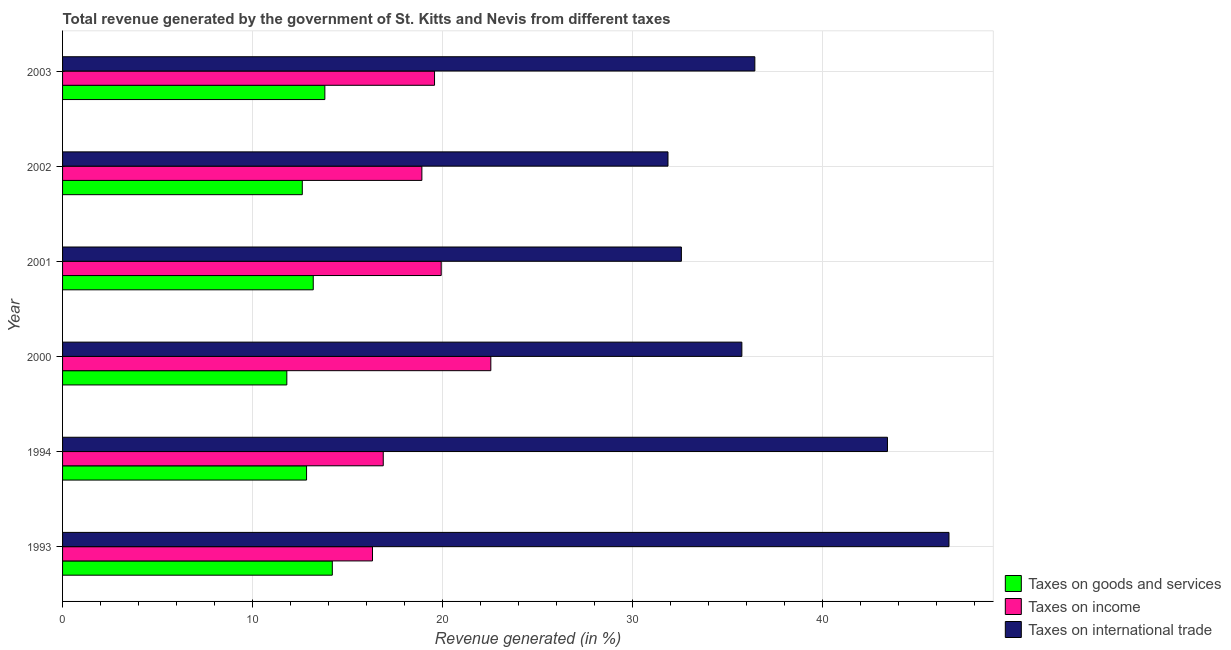How many different coloured bars are there?
Keep it short and to the point. 3. How many groups of bars are there?
Give a very brief answer. 6. Are the number of bars on each tick of the Y-axis equal?
Give a very brief answer. Yes. How many bars are there on the 5th tick from the top?
Give a very brief answer. 3. In how many cases, is the number of bars for a given year not equal to the number of legend labels?
Your response must be concise. 0. What is the percentage of revenue generated by taxes on goods and services in 1994?
Ensure brevity in your answer.  12.84. Across all years, what is the maximum percentage of revenue generated by tax on international trade?
Your response must be concise. 46.64. Across all years, what is the minimum percentage of revenue generated by tax on international trade?
Provide a succinct answer. 31.86. In which year was the percentage of revenue generated by taxes on goods and services maximum?
Make the answer very short. 1993. In which year was the percentage of revenue generated by tax on international trade minimum?
Provide a short and direct response. 2002. What is the total percentage of revenue generated by taxes on income in the graph?
Offer a terse response. 114.12. What is the difference between the percentage of revenue generated by tax on international trade in 1994 and that in 2001?
Provide a short and direct response. 10.84. What is the difference between the percentage of revenue generated by tax on international trade in 2000 and the percentage of revenue generated by taxes on income in 2003?
Give a very brief answer. 16.17. What is the average percentage of revenue generated by taxes on goods and services per year?
Ensure brevity in your answer.  13.07. In the year 1994, what is the difference between the percentage of revenue generated by taxes on goods and services and percentage of revenue generated by taxes on income?
Ensure brevity in your answer.  -4.04. What is the ratio of the percentage of revenue generated by taxes on income in 1994 to that in 2000?
Make the answer very short. 0.75. Is the percentage of revenue generated by tax on international trade in 1994 less than that in 2000?
Provide a short and direct response. No. Is the difference between the percentage of revenue generated by taxes on income in 2001 and 2003 greater than the difference between the percentage of revenue generated by taxes on goods and services in 2001 and 2003?
Provide a succinct answer. Yes. What is the difference between the highest and the second highest percentage of revenue generated by taxes on goods and services?
Make the answer very short. 0.39. What is the difference between the highest and the lowest percentage of revenue generated by taxes on goods and services?
Your answer should be very brief. 2.39. In how many years, is the percentage of revenue generated by taxes on income greater than the average percentage of revenue generated by taxes on income taken over all years?
Your answer should be very brief. 3. What does the 1st bar from the top in 1994 represents?
Provide a short and direct response. Taxes on international trade. What does the 3rd bar from the bottom in 2001 represents?
Provide a succinct answer. Taxes on international trade. How many bars are there?
Offer a terse response. 18. Does the graph contain grids?
Make the answer very short. Yes. Where does the legend appear in the graph?
Offer a very short reply. Bottom right. How many legend labels are there?
Your answer should be compact. 3. How are the legend labels stacked?
Your answer should be compact. Vertical. What is the title of the graph?
Offer a very short reply. Total revenue generated by the government of St. Kitts and Nevis from different taxes. What is the label or title of the X-axis?
Your answer should be very brief. Revenue generated (in %). What is the label or title of the Y-axis?
Your answer should be very brief. Year. What is the Revenue generated (in %) in Taxes on goods and services in 1993?
Keep it short and to the point. 14.19. What is the Revenue generated (in %) of Taxes on income in 1993?
Your answer should be very brief. 16.31. What is the Revenue generated (in %) in Taxes on international trade in 1993?
Your answer should be compact. 46.64. What is the Revenue generated (in %) of Taxes on goods and services in 1994?
Offer a terse response. 12.84. What is the Revenue generated (in %) of Taxes on income in 1994?
Give a very brief answer. 16.87. What is the Revenue generated (in %) in Taxes on international trade in 1994?
Ensure brevity in your answer.  43.41. What is the Revenue generated (in %) of Taxes on goods and services in 2000?
Your response must be concise. 11.8. What is the Revenue generated (in %) of Taxes on income in 2000?
Your answer should be very brief. 22.54. What is the Revenue generated (in %) in Taxes on international trade in 2000?
Make the answer very short. 35.74. What is the Revenue generated (in %) in Taxes on goods and services in 2001?
Offer a very short reply. 13.19. What is the Revenue generated (in %) in Taxes on income in 2001?
Your answer should be very brief. 19.92. What is the Revenue generated (in %) of Taxes on international trade in 2001?
Ensure brevity in your answer.  32.56. What is the Revenue generated (in %) of Taxes on goods and services in 2002?
Your answer should be very brief. 12.61. What is the Revenue generated (in %) of Taxes on income in 2002?
Give a very brief answer. 18.91. What is the Revenue generated (in %) of Taxes on international trade in 2002?
Provide a succinct answer. 31.86. What is the Revenue generated (in %) of Taxes on goods and services in 2003?
Give a very brief answer. 13.8. What is the Revenue generated (in %) of Taxes on income in 2003?
Provide a succinct answer. 19.57. What is the Revenue generated (in %) of Taxes on international trade in 2003?
Your answer should be compact. 36.43. Across all years, what is the maximum Revenue generated (in %) in Taxes on goods and services?
Provide a succinct answer. 14.19. Across all years, what is the maximum Revenue generated (in %) in Taxes on income?
Provide a succinct answer. 22.54. Across all years, what is the maximum Revenue generated (in %) in Taxes on international trade?
Provide a succinct answer. 46.64. Across all years, what is the minimum Revenue generated (in %) of Taxes on goods and services?
Provide a short and direct response. 11.8. Across all years, what is the minimum Revenue generated (in %) of Taxes on income?
Provide a short and direct response. 16.31. Across all years, what is the minimum Revenue generated (in %) of Taxes on international trade?
Give a very brief answer. 31.86. What is the total Revenue generated (in %) of Taxes on goods and services in the graph?
Your answer should be compact. 78.44. What is the total Revenue generated (in %) in Taxes on income in the graph?
Ensure brevity in your answer.  114.12. What is the total Revenue generated (in %) of Taxes on international trade in the graph?
Make the answer very short. 226.64. What is the difference between the Revenue generated (in %) in Taxes on goods and services in 1993 and that in 1994?
Provide a succinct answer. 1.35. What is the difference between the Revenue generated (in %) of Taxes on income in 1993 and that in 1994?
Offer a terse response. -0.57. What is the difference between the Revenue generated (in %) of Taxes on international trade in 1993 and that in 1994?
Give a very brief answer. 3.24. What is the difference between the Revenue generated (in %) in Taxes on goods and services in 1993 and that in 2000?
Give a very brief answer. 2.39. What is the difference between the Revenue generated (in %) in Taxes on income in 1993 and that in 2000?
Make the answer very short. -6.23. What is the difference between the Revenue generated (in %) of Taxes on international trade in 1993 and that in 2000?
Your answer should be compact. 10.9. What is the difference between the Revenue generated (in %) in Taxes on income in 1993 and that in 2001?
Offer a very short reply. -3.62. What is the difference between the Revenue generated (in %) in Taxes on international trade in 1993 and that in 2001?
Your answer should be compact. 14.08. What is the difference between the Revenue generated (in %) in Taxes on goods and services in 1993 and that in 2002?
Keep it short and to the point. 1.58. What is the difference between the Revenue generated (in %) in Taxes on income in 1993 and that in 2002?
Keep it short and to the point. -2.6. What is the difference between the Revenue generated (in %) in Taxes on international trade in 1993 and that in 2002?
Provide a short and direct response. 14.79. What is the difference between the Revenue generated (in %) in Taxes on goods and services in 1993 and that in 2003?
Give a very brief answer. 0.39. What is the difference between the Revenue generated (in %) of Taxes on income in 1993 and that in 2003?
Offer a terse response. -3.26. What is the difference between the Revenue generated (in %) in Taxes on international trade in 1993 and that in 2003?
Your answer should be compact. 10.22. What is the difference between the Revenue generated (in %) of Taxes on goods and services in 1994 and that in 2000?
Make the answer very short. 1.04. What is the difference between the Revenue generated (in %) of Taxes on income in 1994 and that in 2000?
Make the answer very short. -5.66. What is the difference between the Revenue generated (in %) of Taxes on international trade in 1994 and that in 2000?
Keep it short and to the point. 7.66. What is the difference between the Revenue generated (in %) in Taxes on goods and services in 1994 and that in 2001?
Your answer should be compact. -0.35. What is the difference between the Revenue generated (in %) in Taxes on income in 1994 and that in 2001?
Offer a terse response. -3.05. What is the difference between the Revenue generated (in %) in Taxes on international trade in 1994 and that in 2001?
Ensure brevity in your answer.  10.84. What is the difference between the Revenue generated (in %) in Taxes on goods and services in 1994 and that in 2002?
Your response must be concise. 0.22. What is the difference between the Revenue generated (in %) of Taxes on income in 1994 and that in 2002?
Provide a short and direct response. -2.03. What is the difference between the Revenue generated (in %) in Taxes on international trade in 1994 and that in 2002?
Give a very brief answer. 11.55. What is the difference between the Revenue generated (in %) of Taxes on goods and services in 1994 and that in 2003?
Keep it short and to the point. -0.96. What is the difference between the Revenue generated (in %) in Taxes on income in 1994 and that in 2003?
Ensure brevity in your answer.  -2.7. What is the difference between the Revenue generated (in %) in Taxes on international trade in 1994 and that in 2003?
Ensure brevity in your answer.  6.98. What is the difference between the Revenue generated (in %) in Taxes on goods and services in 2000 and that in 2001?
Provide a short and direct response. -1.39. What is the difference between the Revenue generated (in %) of Taxes on income in 2000 and that in 2001?
Provide a succinct answer. 2.61. What is the difference between the Revenue generated (in %) in Taxes on international trade in 2000 and that in 2001?
Offer a terse response. 3.18. What is the difference between the Revenue generated (in %) in Taxes on goods and services in 2000 and that in 2002?
Your answer should be compact. -0.81. What is the difference between the Revenue generated (in %) of Taxes on income in 2000 and that in 2002?
Offer a terse response. 3.63. What is the difference between the Revenue generated (in %) of Taxes on international trade in 2000 and that in 2002?
Provide a short and direct response. 3.89. What is the difference between the Revenue generated (in %) in Taxes on goods and services in 2000 and that in 2003?
Ensure brevity in your answer.  -2. What is the difference between the Revenue generated (in %) in Taxes on income in 2000 and that in 2003?
Ensure brevity in your answer.  2.96. What is the difference between the Revenue generated (in %) in Taxes on international trade in 2000 and that in 2003?
Your answer should be compact. -0.68. What is the difference between the Revenue generated (in %) of Taxes on goods and services in 2001 and that in 2002?
Provide a succinct answer. 0.58. What is the difference between the Revenue generated (in %) of Taxes on income in 2001 and that in 2002?
Give a very brief answer. 1.02. What is the difference between the Revenue generated (in %) in Taxes on international trade in 2001 and that in 2002?
Provide a short and direct response. 0.71. What is the difference between the Revenue generated (in %) in Taxes on goods and services in 2001 and that in 2003?
Your response must be concise. -0.61. What is the difference between the Revenue generated (in %) of Taxes on income in 2001 and that in 2003?
Your answer should be very brief. 0.35. What is the difference between the Revenue generated (in %) in Taxes on international trade in 2001 and that in 2003?
Provide a succinct answer. -3.87. What is the difference between the Revenue generated (in %) in Taxes on goods and services in 2002 and that in 2003?
Ensure brevity in your answer.  -1.19. What is the difference between the Revenue generated (in %) of Taxes on income in 2002 and that in 2003?
Your answer should be very brief. -0.67. What is the difference between the Revenue generated (in %) in Taxes on international trade in 2002 and that in 2003?
Provide a short and direct response. -4.57. What is the difference between the Revenue generated (in %) in Taxes on goods and services in 1993 and the Revenue generated (in %) in Taxes on income in 1994?
Your response must be concise. -2.68. What is the difference between the Revenue generated (in %) in Taxes on goods and services in 1993 and the Revenue generated (in %) in Taxes on international trade in 1994?
Make the answer very short. -29.21. What is the difference between the Revenue generated (in %) of Taxes on income in 1993 and the Revenue generated (in %) of Taxes on international trade in 1994?
Make the answer very short. -27.1. What is the difference between the Revenue generated (in %) in Taxes on goods and services in 1993 and the Revenue generated (in %) in Taxes on income in 2000?
Your response must be concise. -8.34. What is the difference between the Revenue generated (in %) in Taxes on goods and services in 1993 and the Revenue generated (in %) in Taxes on international trade in 2000?
Give a very brief answer. -21.55. What is the difference between the Revenue generated (in %) in Taxes on income in 1993 and the Revenue generated (in %) in Taxes on international trade in 2000?
Your answer should be compact. -19.44. What is the difference between the Revenue generated (in %) in Taxes on goods and services in 1993 and the Revenue generated (in %) in Taxes on income in 2001?
Your answer should be compact. -5.73. What is the difference between the Revenue generated (in %) in Taxes on goods and services in 1993 and the Revenue generated (in %) in Taxes on international trade in 2001?
Make the answer very short. -18.37. What is the difference between the Revenue generated (in %) in Taxes on income in 1993 and the Revenue generated (in %) in Taxes on international trade in 2001?
Give a very brief answer. -16.25. What is the difference between the Revenue generated (in %) of Taxes on goods and services in 1993 and the Revenue generated (in %) of Taxes on income in 2002?
Provide a succinct answer. -4.71. What is the difference between the Revenue generated (in %) in Taxes on goods and services in 1993 and the Revenue generated (in %) in Taxes on international trade in 2002?
Make the answer very short. -17.66. What is the difference between the Revenue generated (in %) of Taxes on income in 1993 and the Revenue generated (in %) of Taxes on international trade in 2002?
Your answer should be very brief. -15.55. What is the difference between the Revenue generated (in %) of Taxes on goods and services in 1993 and the Revenue generated (in %) of Taxes on income in 2003?
Make the answer very short. -5.38. What is the difference between the Revenue generated (in %) in Taxes on goods and services in 1993 and the Revenue generated (in %) in Taxes on international trade in 2003?
Offer a very short reply. -22.23. What is the difference between the Revenue generated (in %) in Taxes on income in 1993 and the Revenue generated (in %) in Taxes on international trade in 2003?
Your answer should be very brief. -20.12. What is the difference between the Revenue generated (in %) in Taxes on goods and services in 1994 and the Revenue generated (in %) in Taxes on income in 2000?
Offer a terse response. -9.7. What is the difference between the Revenue generated (in %) of Taxes on goods and services in 1994 and the Revenue generated (in %) of Taxes on international trade in 2000?
Ensure brevity in your answer.  -22.91. What is the difference between the Revenue generated (in %) of Taxes on income in 1994 and the Revenue generated (in %) of Taxes on international trade in 2000?
Make the answer very short. -18.87. What is the difference between the Revenue generated (in %) of Taxes on goods and services in 1994 and the Revenue generated (in %) of Taxes on income in 2001?
Make the answer very short. -7.09. What is the difference between the Revenue generated (in %) in Taxes on goods and services in 1994 and the Revenue generated (in %) in Taxes on international trade in 2001?
Keep it short and to the point. -19.72. What is the difference between the Revenue generated (in %) in Taxes on income in 1994 and the Revenue generated (in %) in Taxes on international trade in 2001?
Give a very brief answer. -15.69. What is the difference between the Revenue generated (in %) of Taxes on goods and services in 1994 and the Revenue generated (in %) of Taxes on income in 2002?
Your response must be concise. -6.07. What is the difference between the Revenue generated (in %) in Taxes on goods and services in 1994 and the Revenue generated (in %) in Taxes on international trade in 2002?
Ensure brevity in your answer.  -19.02. What is the difference between the Revenue generated (in %) of Taxes on income in 1994 and the Revenue generated (in %) of Taxes on international trade in 2002?
Your response must be concise. -14.98. What is the difference between the Revenue generated (in %) in Taxes on goods and services in 1994 and the Revenue generated (in %) in Taxes on income in 2003?
Ensure brevity in your answer.  -6.73. What is the difference between the Revenue generated (in %) of Taxes on goods and services in 1994 and the Revenue generated (in %) of Taxes on international trade in 2003?
Ensure brevity in your answer.  -23.59. What is the difference between the Revenue generated (in %) in Taxes on income in 1994 and the Revenue generated (in %) in Taxes on international trade in 2003?
Offer a very short reply. -19.55. What is the difference between the Revenue generated (in %) in Taxes on goods and services in 2000 and the Revenue generated (in %) in Taxes on income in 2001?
Offer a very short reply. -8.12. What is the difference between the Revenue generated (in %) of Taxes on goods and services in 2000 and the Revenue generated (in %) of Taxes on international trade in 2001?
Your answer should be compact. -20.76. What is the difference between the Revenue generated (in %) in Taxes on income in 2000 and the Revenue generated (in %) in Taxes on international trade in 2001?
Your response must be concise. -10.03. What is the difference between the Revenue generated (in %) in Taxes on goods and services in 2000 and the Revenue generated (in %) in Taxes on income in 2002?
Make the answer very short. -7.11. What is the difference between the Revenue generated (in %) of Taxes on goods and services in 2000 and the Revenue generated (in %) of Taxes on international trade in 2002?
Make the answer very short. -20.06. What is the difference between the Revenue generated (in %) of Taxes on income in 2000 and the Revenue generated (in %) of Taxes on international trade in 2002?
Ensure brevity in your answer.  -9.32. What is the difference between the Revenue generated (in %) in Taxes on goods and services in 2000 and the Revenue generated (in %) in Taxes on income in 2003?
Ensure brevity in your answer.  -7.77. What is the difference between the Revenue generated (in %) of Taxes on goods and services in 2000 and the Revenue generated (in %) of Taxes on international trade in 2003?
Make the answer very short. -24.63. What is the difference between the Revenue generated (in %) in Taxes on income in 2000 and the Revenue generated (in %) in Taxes on international trade in 2003?
Make the answer very short. -13.89. What is the difference between the Revenue generated (in %) of Taxes on goods and services in 2001 and the Revenue generated (in %) of Taxes on income in 2002?
Provide a short and direct response. -5.72. What is the difference between the Revenue generated (in %) in Taxes on goods and services in 2001 and the Revenue generated (in %) in Taxes on international trade in 2002?
Your answer should be compact. -18.67. What is the difference between the Revenue generated (in %) in Taxes on income in 2001 and the Revenue generated (in %) in Taxes on international trade in 2002?
Offer a very short reply. -11.93. What is the difference between the Revenue generated (in %) of Taxes on goods and services in 2001 and the Revenue generated (in %) of Taxes on income in 2003?
Offer a terse response. -6.38. What is the difference between the Revenue generated (in %) of Taxes on goods and services in 2001 and the Revenue generated (in %) of Taxes on international trade in 2003?
Keep it short and to the point. -23.24. What is the difference between the Revenue generated (in %) in Taxes on income in 2001 and the Revenue generated (in %) in Taxes on international trade in 2003?
Provide a succinct answer. -16.5. What is the difference between the Revenue generated (in %) of Taxes on goods and services in 2002 and the Revenue generated (in %) of Taxes on income in 2003?
Keep it short and to the point. -6.96. What is the difference between the Revenue generated (in %) in Taxes on goods and services in 2002 and the Revenue generated (in %) in Taxes on international trade in 2003?
Your response must be concise. -23.81. What is the difference between the Revenue generated (in %) in Taxes on income in 2002 and the Revenue generated (in %) in Taxes on international trade in 2003?
Make the answer very short. -17.52. What is the average Revenue generated (in %) of Taxes on goods and services per year?
Offer a very short reply. 13.07. What is the average Revenue generated (in %) of Taxes on income per year?
Make the answer very short. 19.02. What is the average Revenue generated (in %) of Taxes on international trade per year?
Provide a short and direct response. 37.77. In the year 1993, what is the difference between the Revenue generated (in %) of Taxes on goods and services and Revenue generated (in %) of Taxes on income?
Ensure brevity in your answer.  -2.12. In the year 1993, what is the difference between the Revenue generated (in %) of Taxes on goods and services and Revenue generated (in %) of Taxes on international trade?
Provide a short and direct response. -32.45. In the year 1993, what is the difference between the Revenue generated (in %) in Taxes on income and Revenue generated (in %) in Taxes on international trade?
Give a very brief answer. -30.33. In the year 1994, what is the difference between the Revenue generated (in %) in Taxes on goods and services and Revenue generated (in %) in Taxes on income?
Offer a terse response. -4.04. In the year 1994, what is the difference between the Revenue generated (in %) in Taxes on goods and services and Revenue generated (in %) in Taxes on international trade?
Your response must be concise. -30.57. In the year 1994, what is the difference between the Revenue generated (in %) of Taxes on income and Revenue generated (in %) of Taxes on international trade?
Provide a succinct answer. -26.53. In the year 2000, what is the difference between the Revenue generated (in %) of Taxes on goods and services and Revenue generated (in %) of Taxes on income?
Provide a short and direct response. -10.73. In the year 2000, what is the difference between the Revenue generated (in %) in Taxes on goods and services and Revenue generated (in %) in Taxes on international trade?
Make the answer very short. -23.94. In the year 2000, what is the difference between the Revenue generated (in %) of Taxes on income and Revenue generated (in %) of Taxes on international trade?
Your answer should be compact. -13.21. In the year 2001, what is the difference between the Revenue generated (in %) in Taxes on goods and services and Revenue generated (in %) in Taxes on income?
Ensure brevity in your answer.  -6.73. In the year 2001, what is the difference between the Revenue generated (in %) of Taxes on goods and services and Revenue generated (in %) of Taxes on international trade?
Offer a terse response. -19.37. In the year 2001, what is the difference between the Revenue generated (in %) in Taxes on income and Revenue generated (in %) in Taxes on international trade?
Your answer should be very brief. -12.64. In the year 2002, what is the difference between the Revenue generated (in %) in Taxes on goods and services and Revenue generated (in %) in Taxes on income?
Your answer should be very brief. -6.29. In the year 2002, what is the difference between the Revenue generated (in %) of Taxes on goods and services and Revenue generated (in %) of Taxes on international trade?
Your response must be concise. -19.24. In the year 2002, what is the difference between the Revenue generated (in %) in Taxes on income and Revenue generated (in %) in Taxes on international trade?
Provide a succinct answer. -12.95. In the year 2003, what is the difference between the Revenue generated (in %) of Taxes on goods and services and Revenue generated (in %) of Taxes on income?
Make the answer very short. -5.77. In the year 2003, what is the difference between the Revenue generated (in %) of Taxes on goods and services and Revenue generated (in %) of Taxes on international trade?
Give a very brief answer. -22.63. In the year 2003, what is the difference between the Revenue generated (in %) in Taxes on income and Revenue generated (in %) in Taxes on international trade?
Provide a short and direct response. -16.86. What is the ratio of the Revenue generated (in %) of Taxes on goods and services in 1993 to that in 1994?
Your response must be concise. 1.11. What is the ratio of the Revenue generated (in %) of Taxes on income in 1993 to that in 1994?
Provide a succinct answer. 0.97. What is the ratio of the Revenue generated (in %) in Taxes on international trade in 1993 to that in 1994?
Offer a very short reply. 1.07. What is the ratio of the Revenue generated (in %) in Taxes on goods and services in 1993 to that in 2000?
Provide a succinct answer. 1.2. What is the ratio of the Revenue generated (in %) of Taxes on income in 1993 to that in 2000?
Ensure brevity in your answer.  0.72. What is the ratio of the Revenue generated (in %) of Taxes on international trade in 1993 to that in 2000?
Make the answer very short. 1.3. What is the ratio of the Revenue generated (in %) of Taxes on goods and services in 1993 to that in 2001?
Your response must be concise. 1.08. What is the ratio of the Revenue generated (in %) in Taxes on income in 1993 to that in 2001?
Keep it short and to the point. 0.82. What is the ratio of the Revenue generated (in %) in Taxes on international trade in 1993 to that in 2001?
Provide a short and direct response. 1.43. What is the ratio of the Revenue generated (in %) in Taxes on goods and services in 1993 to that in 2002?
Provide a short and direct response. 1.13. What is the ratio of the Revenue generated (in %) of Taxes on income in 1993 to that in 2002?
Keep it short and to the point. 0.86. What is the ratio of the Revenue generated (in %) of Taxes on international trade in 1993 to that in 2002?
Offer a very short reply. 1.46. What is the ratio of the Revenue generated (in %) in Taxes on goods and services in 1993 to that in 2003?
Give a very brief answer. 1.03. What is the ratio of the Revenue generated (in %) of Taxes on international trade in 1993 to that in 2003?
Give a very brief answer. 1.28. What is the ratio of the Revenue generated (in %) in Taxes on goods and services in 1994 to that in 2000?
Offer a very short reply. 1.09. What is the ratio of the Revenue generated (in %) in Taxes on income in 1994 to that in 2000?
Provide a succinct answer. 0.75. What is the ratio of the Revenue generated (in %) of Taxes on international trade in 1994 to that in 2000?
Keep it short and to the point. 1.21. What is the ratio of the Revenue generated (in %) in Taxes on goods and services in 1994 to that in 2001?
Your answer should be very brief. 0.97. What is the ratio of the Revenue generated (in %) in Taxes on income in 1994 to that in 2001?
Ensure brevity in your answer.  0.85. What is the ratio of the Revenue generated (in %) of Taxes on international trade in 1994 to that in 2001?
Provide a short and direct response. 1.33. What is the ratio of the Revenue generated (in %) of Taxes on goods and services in 1994 to that in 2002?
Make the answer very short. 1.02. What is the ratio of the Revenue generated (in %) in Taxes on income in 1994 to that in 2002?
Offer a terse response. 0.89. What is the ratio of the Revenue generated (in %) in Taxes on international trade in 1994 to that in 2002?
Your answer should be compact. 1.36. What is the ratio of the Revenue generated (in %) of Taxes on goods and services in 1994 to that in 2003?
Provide a succinct answer. 0.93. What is the ratio of the Revenue generated (in %) in Taxes on income in 1994 to that in 2003?
Your response must be concise. 0.86. What is the ratio of the Revenue generated (in %) of Taxes on international trade in 1994 to that in 2003?
Provide a short and direct response. 1.19. What is the ratio of the Revenue generated (in %) in Taxes on goods and services in 2000 to that in 2001?
Provide a succinct answer. 0.89. What is the ratio of the Revenue generated (in %) in Taxes on income in 2000 to that in 2001?
Ensure brevity in your answer.  1.13. What is the ratio of the Revenue generated (in %) of Taxes on international trade in 2000 to that in 2001?
Keep it short and to the point. 1.1. What is the ratio of the Revenue generated (in %) in Taxes on goods and services in 2000 to that in 2002?
Ensure brevity in your answer.  0.94. What is the ratio of the Revenue generated (in %) of Taxes on income in 2000 to that in 2002?
Your answer should be very brief. 1.19. What is the ratio of the Revenue generated (in %) in Taxes on international trade in 2000 to that in 2002?
Keep it short and to the point. 1.12. What is the ratio of the Revenue generated (in %) of Taxes on goods and services in 2000 to that in 2003?
Provide a succinct answer. 0.85. What is the ratio of the Revenue generated (in %) of Taxes on income in 2000 to that in 2003?
Provide a succinct answer. 1.15. What is the ratio of the Revenue generated (in %) of Taxes on international trade in 2000 to that in 2003?
Provide a short and direct response. 0.98. What is the ratio of the Revenue generated (in %) of Taxes on goods and services in 2001 to that in 2002?
Provide a short and direct response. 1.05. What is the ratio of the Revenue generated (in %) of Taxes on income in 2001 to that in 2002?
Give a very brief answer. 1.05. What is the ratio of the Revenue generated (in %) in Taxes on international trade in 2001 to that in 2002?
Make the answer very short. 1.02. What is the ratio of the Revenue generated (in %) in Taxes on goods and services in 2001 to that in 2003?
Make the answer very short. 0.96. What is the ratio of the Revenue generated (in %) in Taxes on income in 2001 to that in 2003?
Your response must be concise. 1.02. What is the ratio of the Revenue generated (in %) in Taxes on international trade in 2001 to that in 2003?
Your answer should be very brief. 0.89. What is the ratio of the Revenue generated (in %) in Taxes on goods and services in 2002 to that in 2003?
Make the answer very short. 0.91. What is the ratio of the Revenue generated (in %) in Taxes on international trade in 2002 to that in 2003?
Provide a succinct answer. 0.87. What is the difference between the highest and the second highest Revenue generated (in %) of Taxes on goods and services?
Keep it short and to the point. 0.39. What is the difference between the highest and the second highest Revenue generated (in %) of Taxes on income?
Make the answer very short. 2.61. What is the difference between the highest and the second highest Revenue generated (in %) of Taxes on international trade?
Give a very brief answer. 3.24. What is the difference between the highest and the lowest Revenue generated (in %) of Taxes on goods and services?
Keep it short and to the point. 2.39. What is the difference between the highest and the lowest Revenue generated (in %) in Taxes on income?
Your answer should be compact. 6.23. What is the difference between the highest and the lowest Revenue generated (in %) of Taxes on international trade?
Keep it short and to the point. 14.79. 